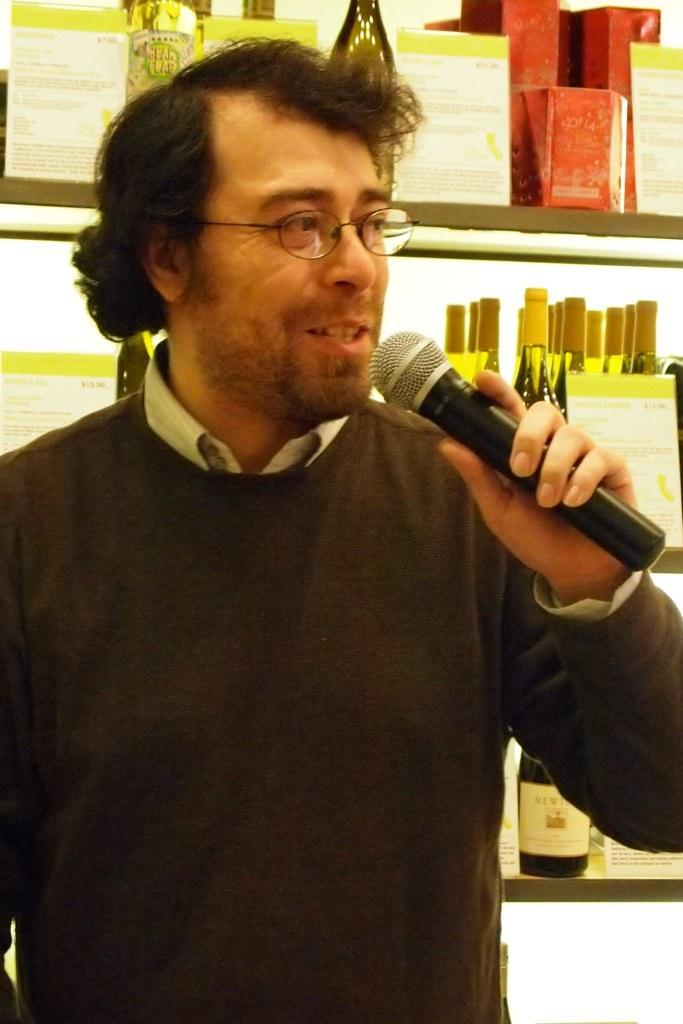What is the man in the image doing? The man is holding a mic and speaking. What object is the man holding in the image? The man is holding a mic. What can be seen in the background of the image? There are many bottles, a poster, and a box in the background of the image. What type of dog can be seen playing with the man in the image? There is no dog present in the image; the man is holding a mic and speaking. What can be seen coming out of the man's nose in the image? There is no indication of the man's nose or anything coming out of it in the image. 